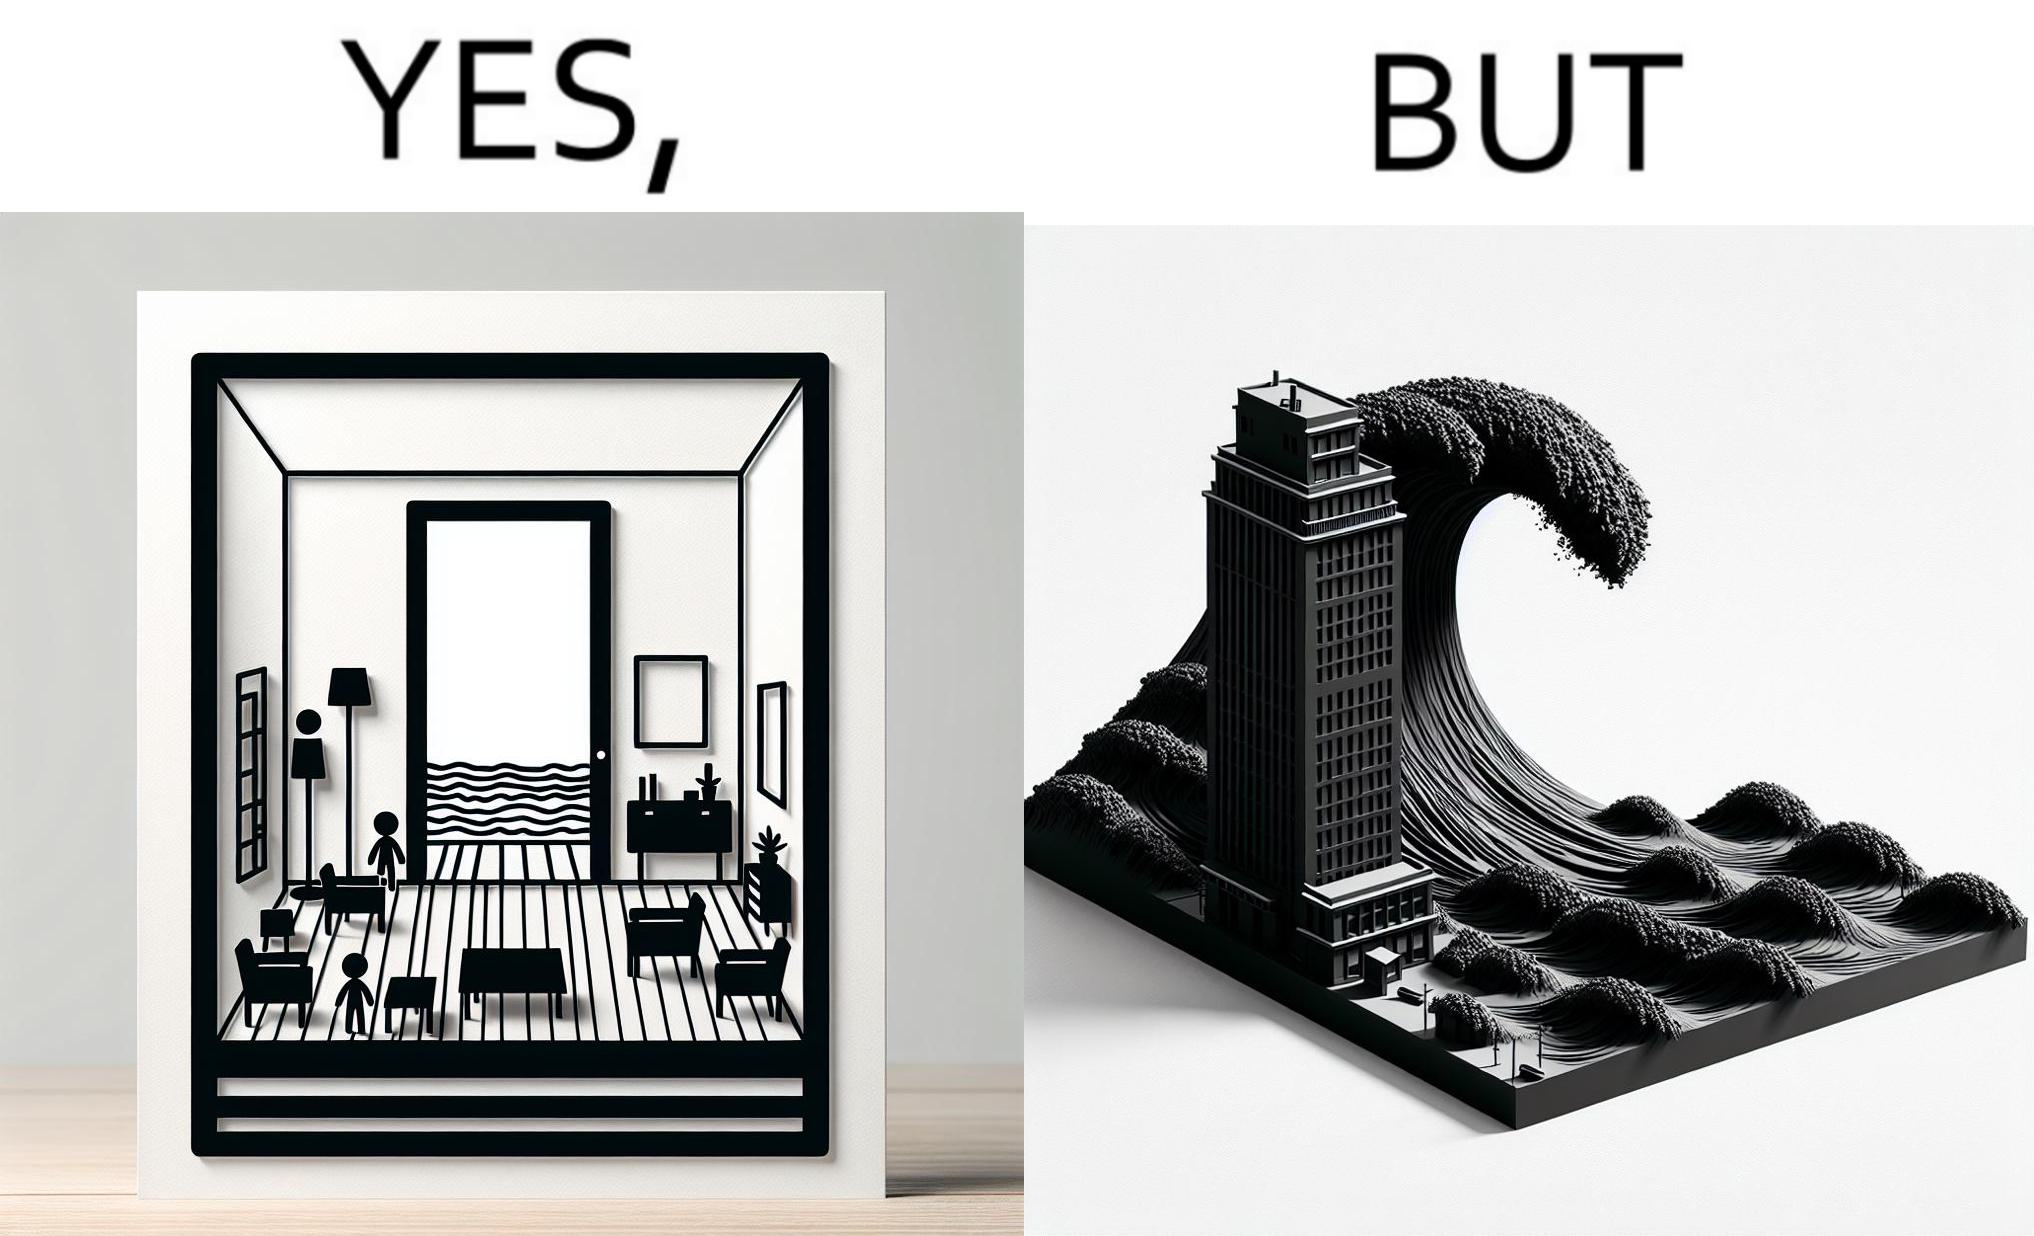What makes this image funny or satirical? The same sea which gives us a relaxation on a normal day can pose a danger to us sometimes like during a tsunami 